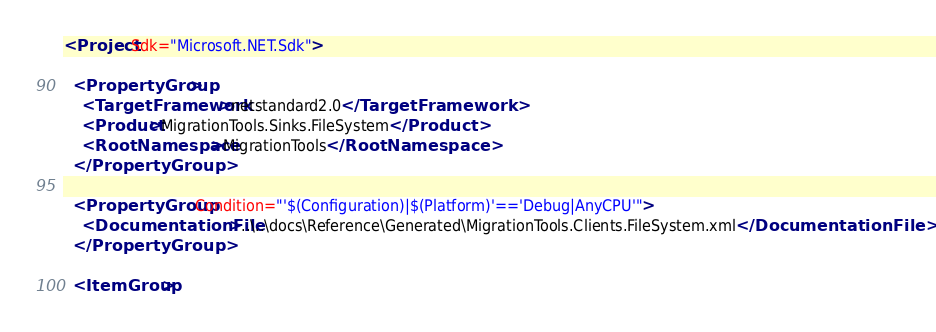Convert code to text. <code><loc_0><loc_0><loc_500><loc_500><_XML_><Project Sdk="Microsoft.NET.Sdk">

  <PropertyGroup>
    <TargetFramework>netstandard2.0</TargetFramework>
    <Product>MigrationTools.Sinks.FileSystem</Product>
    <RootNamespace>MigrationTools</RootNamespace>
  </PropertyGroup>

  <PropertyGroup Condition="'$(Configuration)|$(Platform)'=='Debug|AnyCPU'">
    <DocumentationFile>..\..\docs\Reference\Generated\MigrationTools.Clients.FileSystem.xml</DocumentationFile>
  </PropertyGroup>

  <ItemGroup></code> 